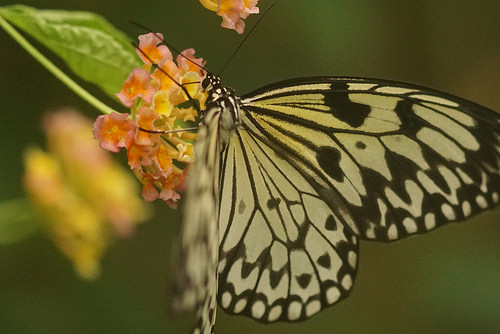<image>
Is there a butterfly on the flower? Yes. Looking at the image, I can see the butterfly is positioned on top of the flower, with the flower providing support. 